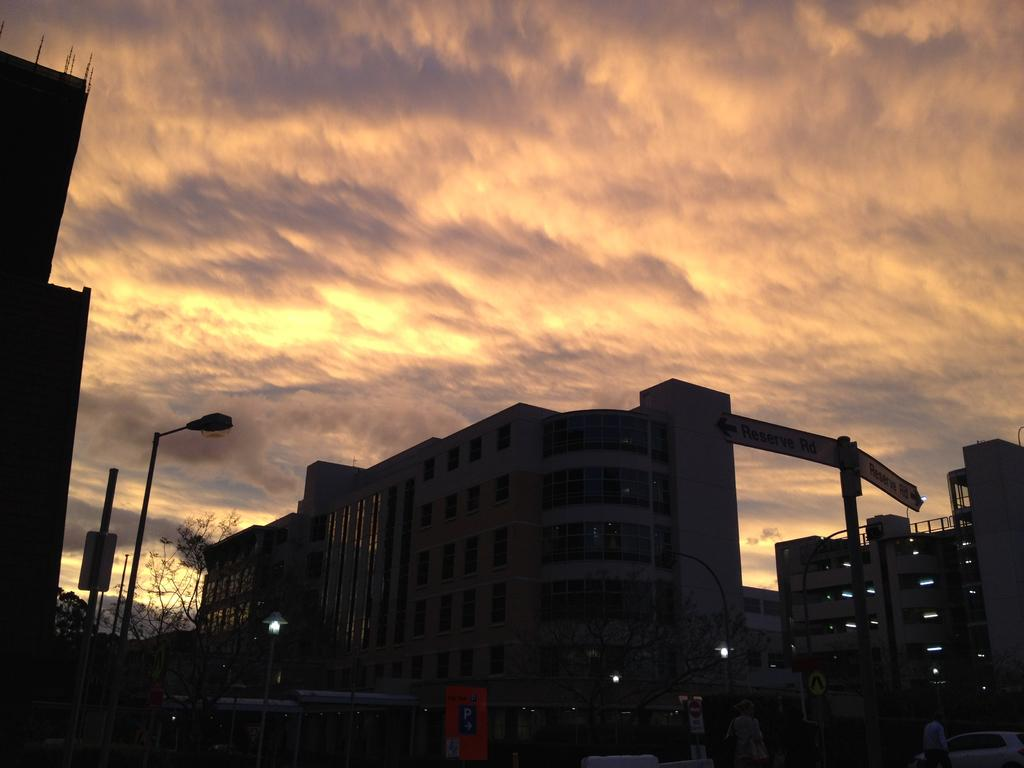What is the weather condition in the image? The sky is cloudy in the image. What type of structures can be seen in the image? There are buildings in the image. What are the signboards used for in the image? The signboards provide information or advertisements in the image. What are the light poles used for in the image? The light poles provide illumination in the image. Who or what is present in the image? There are people in the image. What mode of transportation is visible in the image? There is a vehicle in the image. What type of vegetation is present in the image? There are trees in the image. Can you tell me how many cats are running on the light poles in the image? There are no cats present in the image, and therefore no such activity can be observed. 